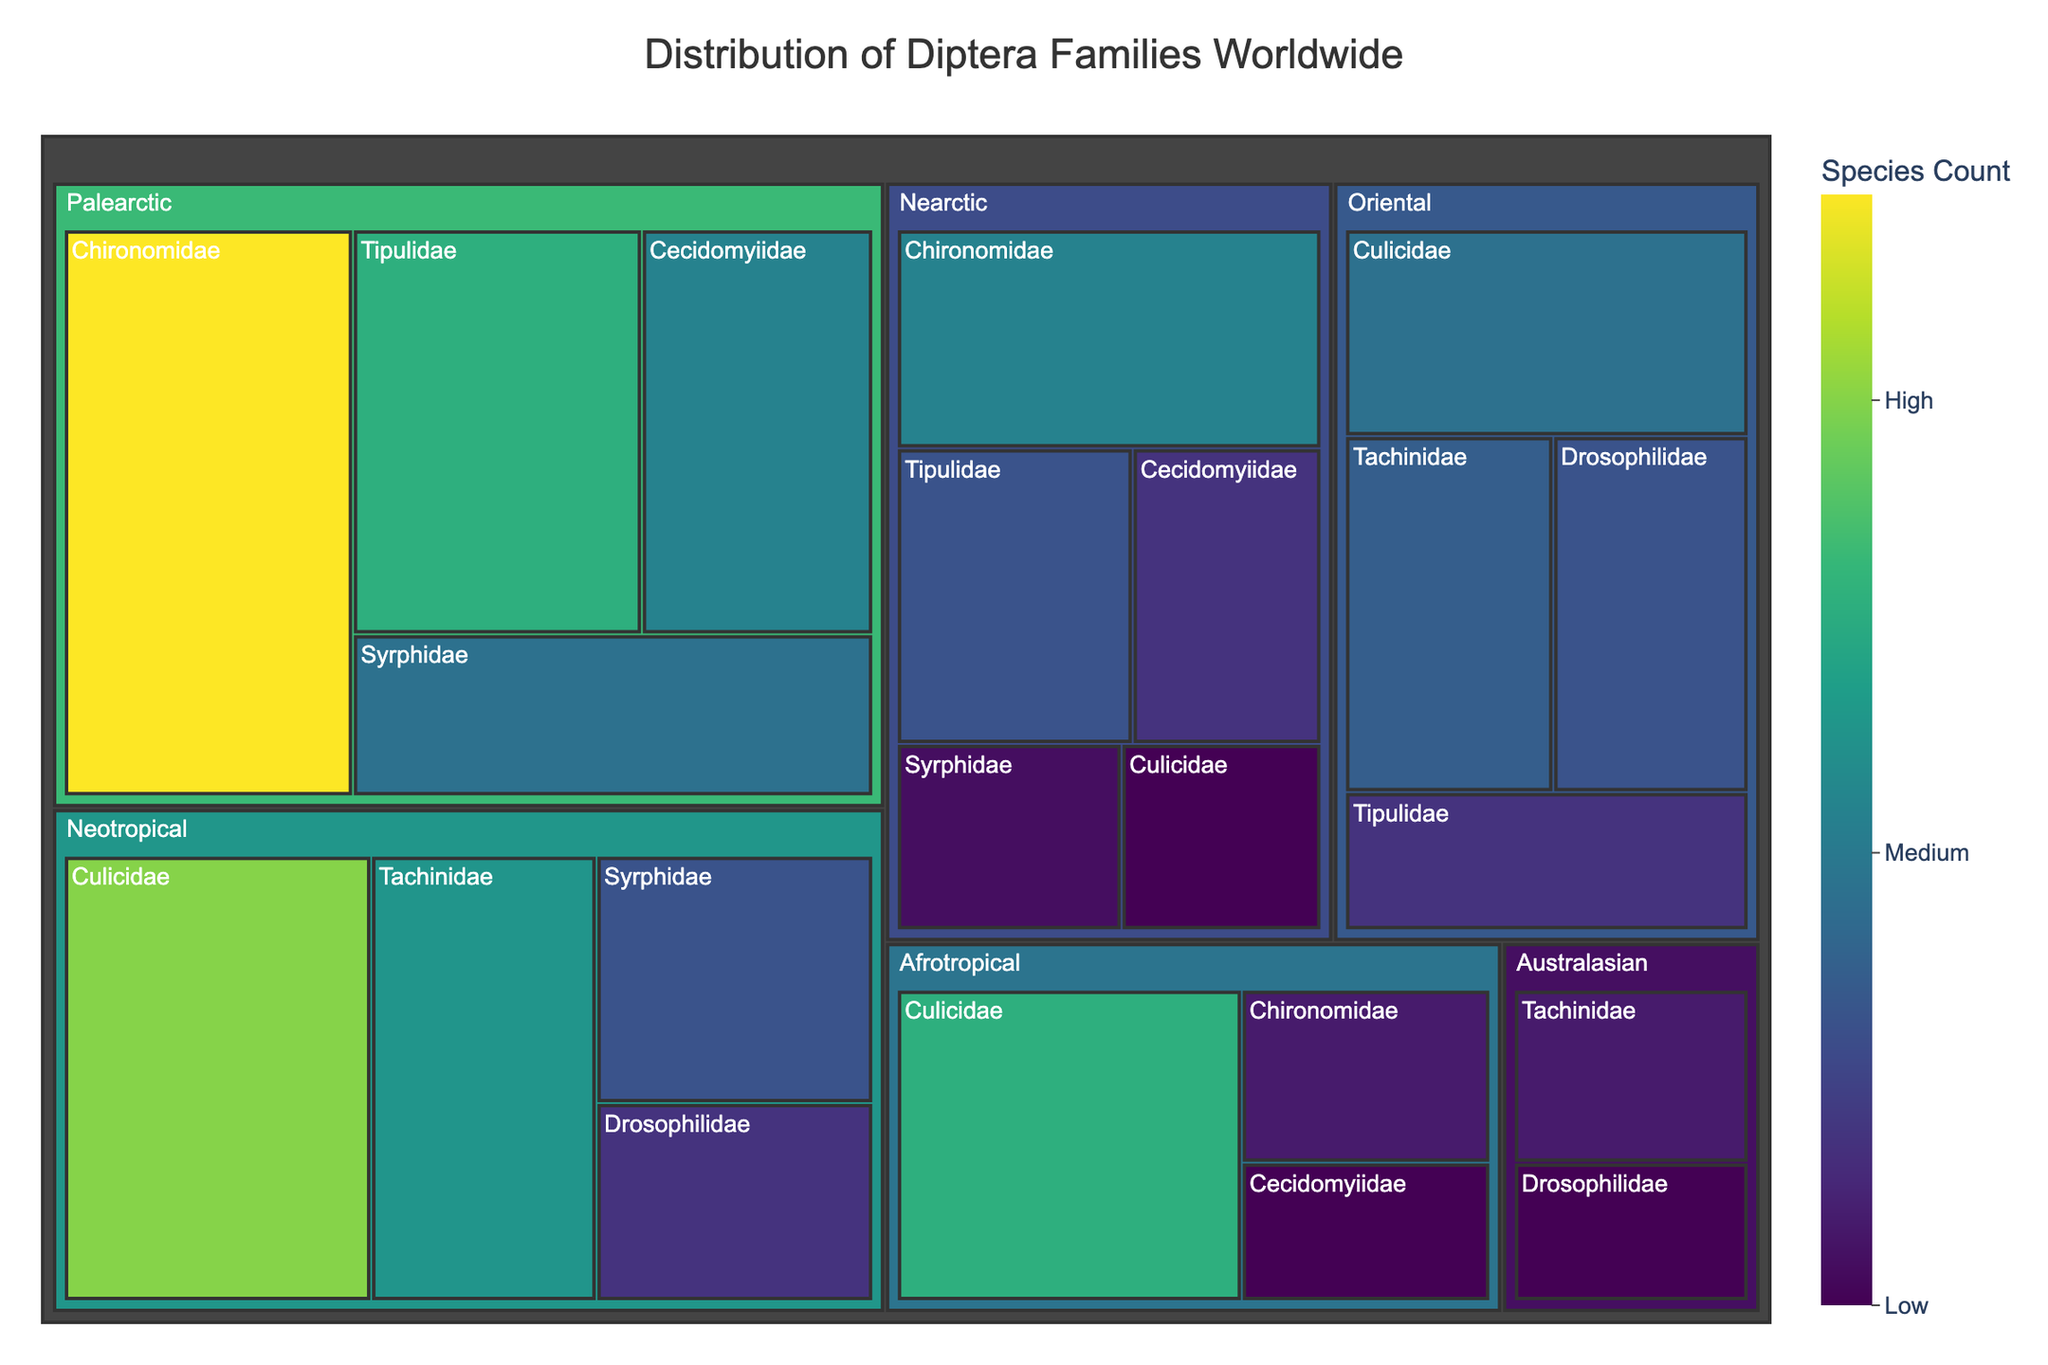Which Diptera family has the highest number of species in the Palearctic region? To find this, look for the family with the largest block in the Palearctic section. Chironomidae has the largest area with 3500 species.
Answer: Chironomidae Which region has the most diverse distribution of Diptera families? To determine this, observe which region has the most distinct family blocks. The Palearctic and Neotropical regions each have multiple families, but the Palearctic has more family variations with 4 families represented.
Answer: Palearctic How many Diptera species are there in the Nearctic region across all families combined? Sum the species counts for all families in the Nearctic region: Culicidae (800) + Tipulidae (1500) + Chironomidae (2000) + Syrphidae (900) + Cecidomyiidae (1200). The total is 800 + 1500 + 2000 + 900 + 1200 = 6400.
Answer: 6400 Which family in the Oriental region has more species, Culicidae or Drosophilidae? Compare the species counts for each family in the Oriental region. Culicidae has 1800 species, while Drosophilidae has 1500 species. Therefore, Culicidae has more species.
Answer: Culicidae What is the total species count for the family Syrphidae across all regions? Sum the species counts for Syrphidae in all regions: Palearctic (1800) + Neotropical (1500) + Nearctic (900). The total is 1800 + 1500 + 900 = 4200.
Answer: 4200 In which region is the family Culicidae least represented? Look for the smallest block for the family Culicidae across all regions. The smallest count is in the Nearctic region with 800 species.
Answer: Nearctic Is there a region where both Culicidae and Chironomidae families are present? Check each region to see if both families are present. Both families are present in the Afrotropical and Nearctic regions.
Answer: Afrotropical and Nearctic Which family has the second highest species count in the Neotropical region? Identify the top two highest species counts in the Neotropical region. The highest is Culicidae with 3000 species, and the second highest is Tachinidae with 2200 species.
Answer: Tachinidae 